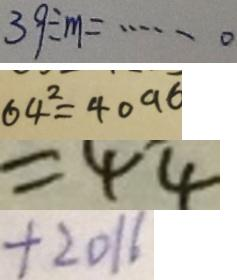<formula> <loc_0><loc_0><loc_500><loc_500>3 9 \div m = \cdots 0 
 6 4 ^ { 2 } = 4 0 9 6 
 = 4 4 
 + 2 0 1 6</formula> 